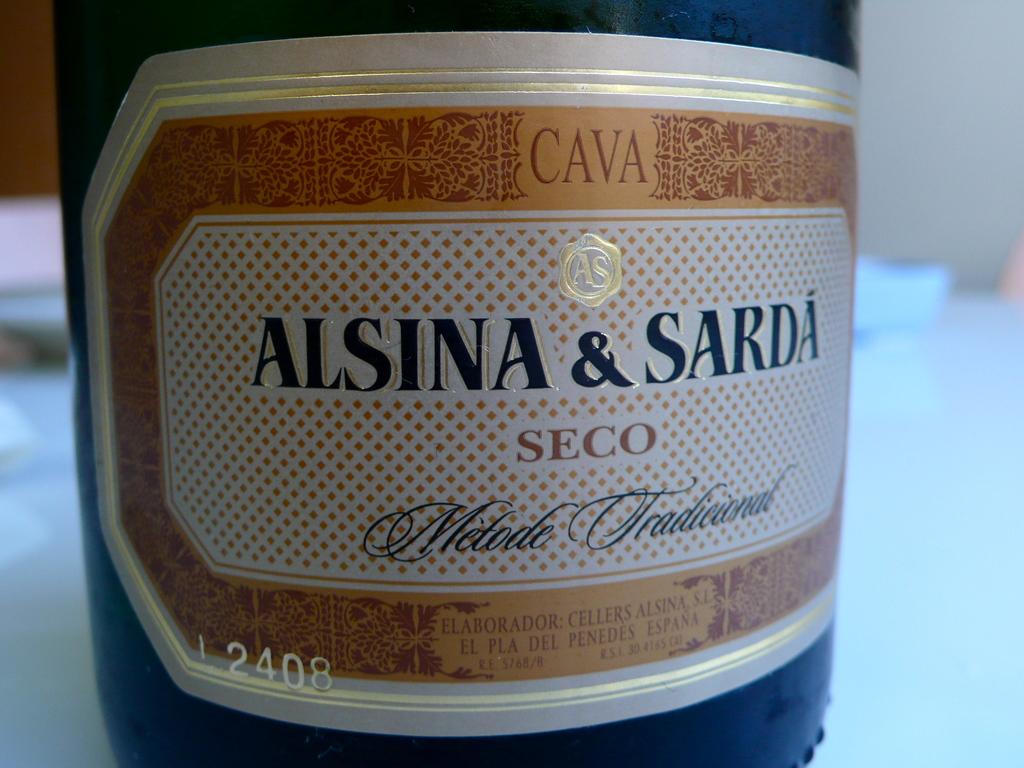What country is it made in ?
Your answer should be very brief. Unanswerable. It says alsina & what?
Offer a terse response. Sarda. 